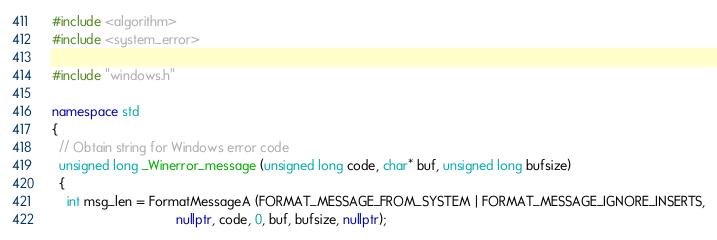<code> <loc_0><loc_0><loc_500><loc_500><_C++_>#include <algorithm>
#include <system_error>

#include "windows.h"

namespace std
{
  // Obtain string for Windows error code
  unsigned long _Winerror_message (unsigned long code, char* buf, unsigned long bufsize)
  {
    int msg_len = FormatMessageA (FORMAT_MESSAGE_FROM_SYSTEM | FORMAT_MESSAGE_IGNORE_INSERTS,
                                  nullptr, code, 0, buf, bufsize, nullptr);</code> 